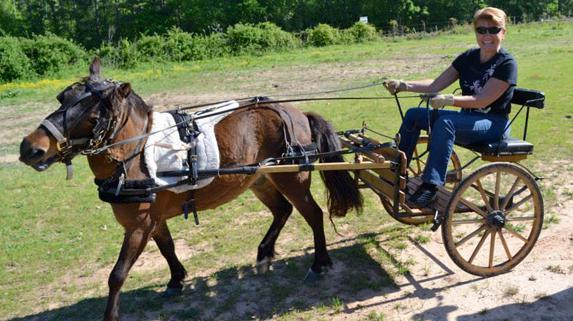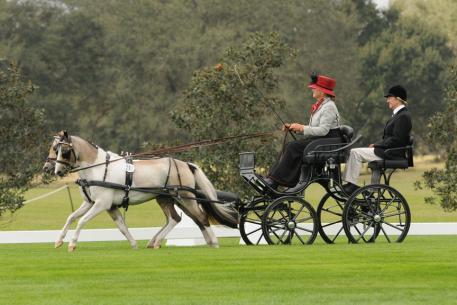The first image is the image on the left, the second image is the image on the right. Assess this claim about the two images: "One cart with two wheels is driven by a man and one by a woman, each holding a whip, to control the single horse.". Correct or not? Answer yes or no. No. 